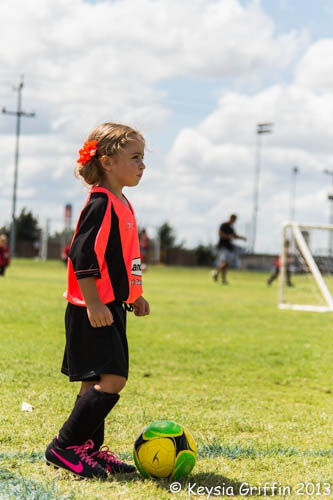Describe the objects in this image and their specific colors. I can see people in white, black, red, and maroon tones, sports ball in white, olive, gold, and black tones, people in white, black, gray, and olive tones, people in white, darkgreen, gray, and tan tones, and people in white, maroon, black, and brown tones in this image. 